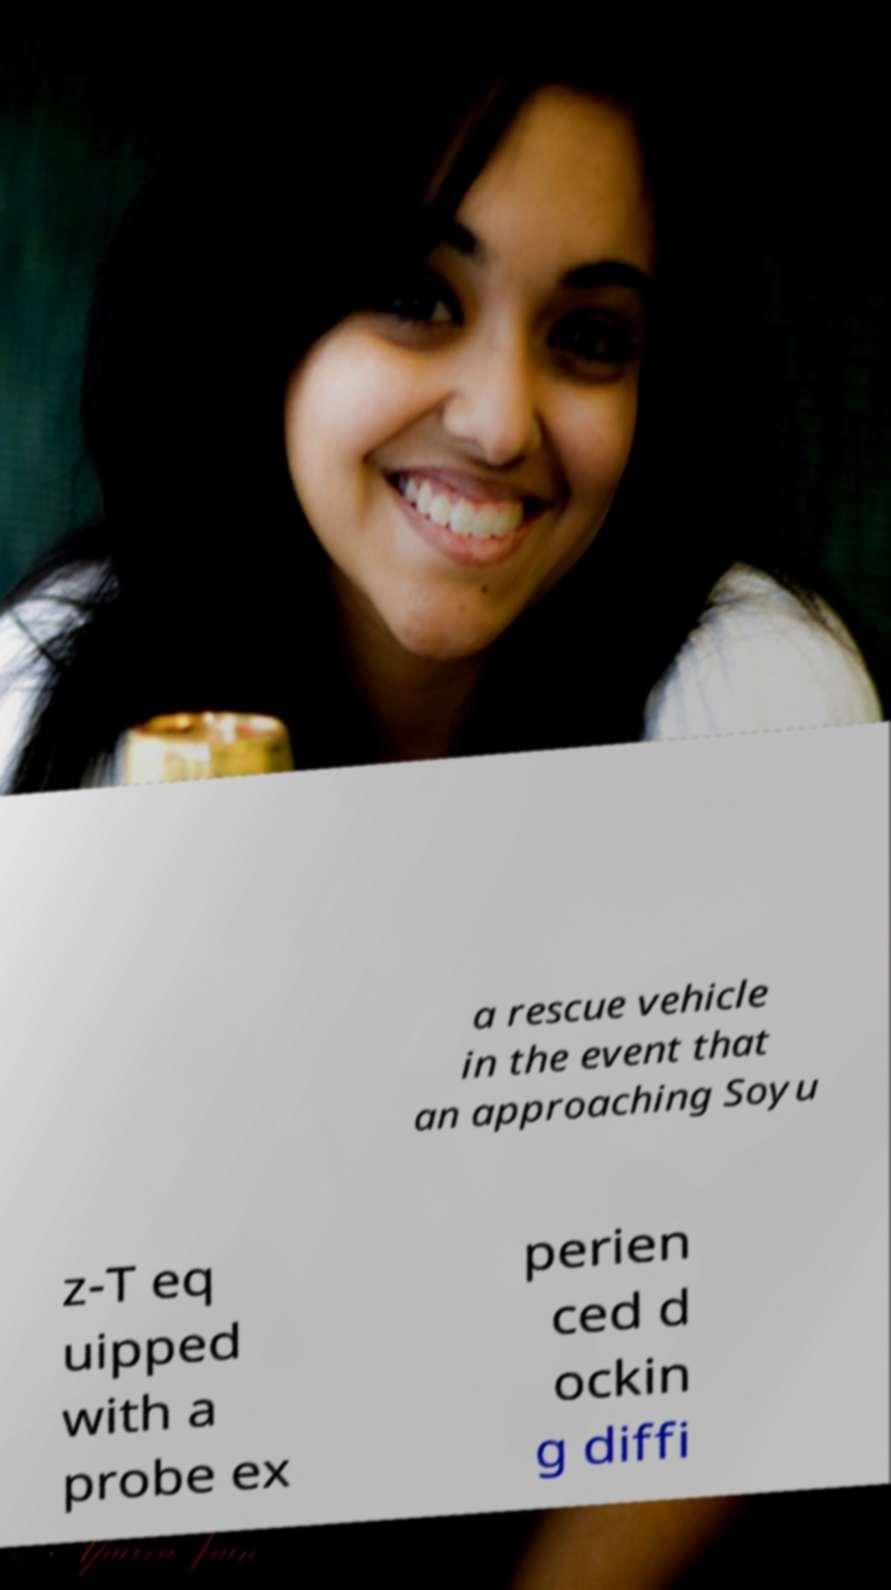Can you read and provide the text displayed in the image?This photo seems to have some interesting text. Can you extract and type it out for me? a rescue vehicle in the event that an approaching Soyu z-T eq uipped with a probe ex perien ced d ockin g diffi 